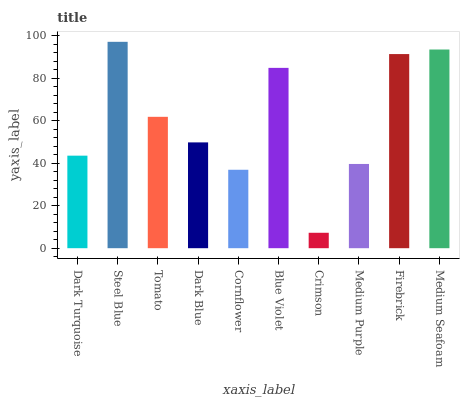Is Tomato the minimum?
Answer yes or no. No. Is Tomato the maximum?
Answer yes or no. No. Is Steel Blue greater than Tomato?
Answer yes or no. Yes. Is Tomato less than Steel Blue?
Answer yes or no. Yes. Is Tomato greater than Steel Blue?
Answer yes or no. No. Is Steel Blue less than Tomato?
Answer yes or no. No. Is Tomato the high median?
Answer yes or no. Yes. Is Dark Blue the low median?
Answer yes or no. Yes. Is Cornflower the high median?
Answer yes or no. No. Is Firebrick the low median?
Answer yes or no. No. 